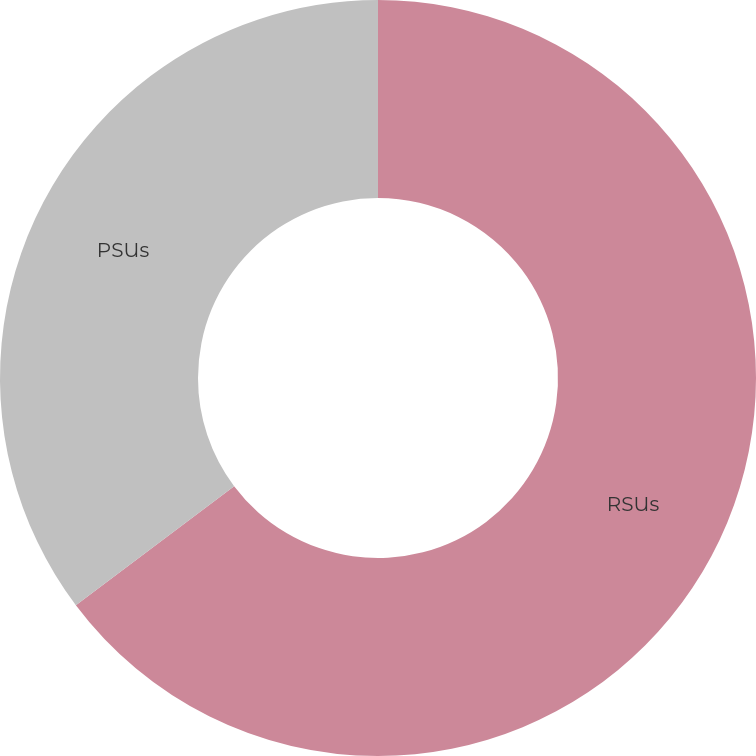Convert chart to OTSL. <chart><loc_0><loc_0><loc_500><loc_500><pie_chart><fcel>RSUs<fcel>PSUs<nl><fcel>64.74%<fcel>35.26%<nl></chart> 